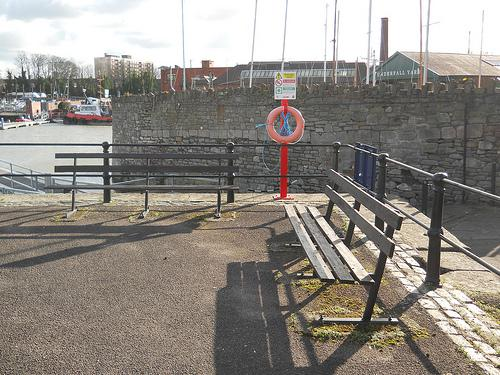Question: what is this a picture of?
Choices:
A. The seashore.
B. The lakefront.
C. The body of water.
D. The ocean.
Answer with the letter. Answer: C Question: what do the two benches represent?
Choices:
A. A place for tired people to sit.
B. Places to sit and observe the body of water.
C. Seating in a park to relax.
D. Seating for those waiting for a bus.
Answer with the letter. Answer: B Question: where was this picture taken?
Choices:
A. Near a swimming pool.
B. Close to a shipyard and a large body of water.
C. At the drydock.
D. By a marina.
Answer with the letter. Answer: B 